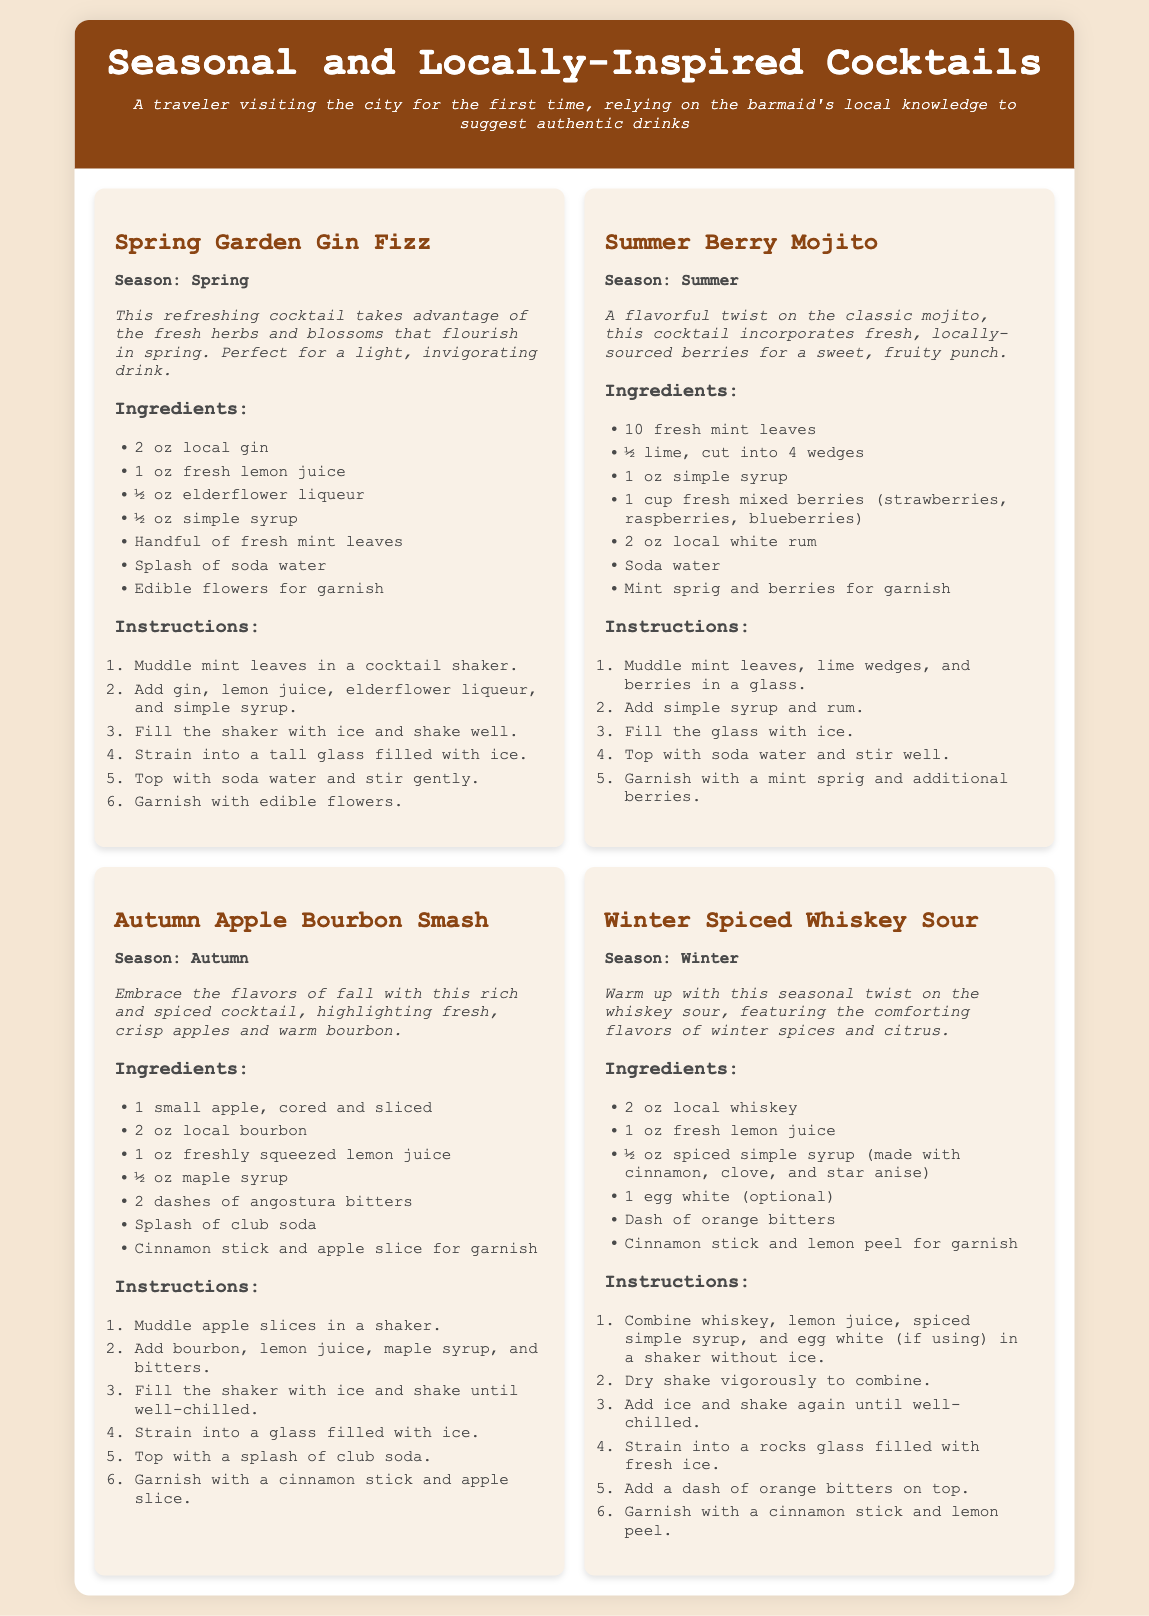What is the name of the spring cocktail? The name of the spring cocktail is mentioned at the beginning of the corresponding section, which is "Spring Garden Gin Fizz."
Answer: Spring Garden Gin Fizz How many ounces of local gin are required for the Spring Garden Gin Fizz? The ingredients list shows that 2 ounces of local gin are needed for this cocktail.
Answer: 2 oz What season is the Winter Spiced Whiskey Sour associated with? The season specified for the Winter Spiced Whiskey Sour is mentioned directly in its title section as "Winter."
Answer: Winter What type of spirits are used in the Autumn Apple Bourbon Smash? The ingredients list for the Autumn Apple Bourbon Smash clearly states that local bourbon is used as the spirit in this recipe.
Answer: Bourbon Which cocktail includes elderflower liqueur as an ingredient? The Spring Garden Gin Fizz is the only cocktail listed that includes elderflower liqueur in its ingredients.
Answer: Spring Garden Gin Fizz What is the garnish for the Summer Berry Mojito? The ingredients section lists that a mint sprig and berries are used for garnishing the Summer Berry Mojito.
Answer: Mint sprig and berries What is the common ingredient in all cocktails? All cocktails feature fresh ingredients, which can be seen in the various ingredients listed for each of the cocktails.
Answer: Fresh ingredients How is the Winter Spiced Whiskey Sour shaken? The instructions specify that the ingredients should be "dry shake vigorously to combine" before shaking it with ice.
Answer: Dry shake vigorously What type of syrup is used in the Winter Spiced Whiskey Sour? The ingredients list shows that a spiced simple syrup is used, made with cinnamon, clove, and star anise.
Answer: Spiced simple syrup 